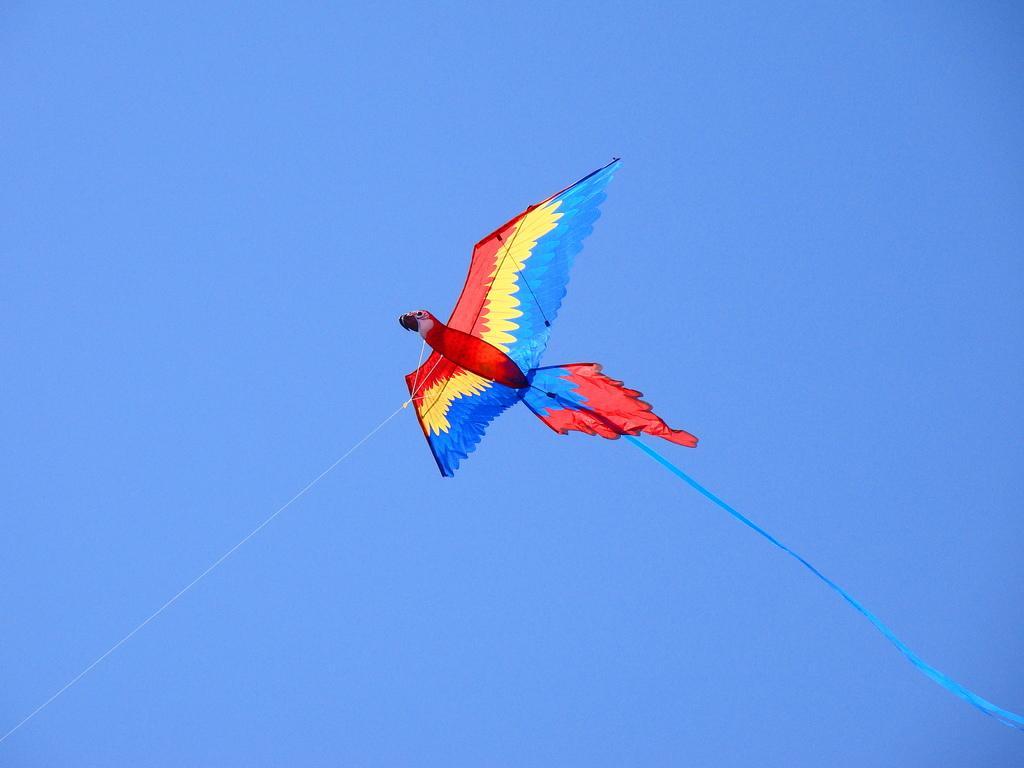Could you give a brief overview of what you see in this image? In this image, we can see a kite with threads and ribbon in the air. Background there is a clear sky. 